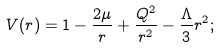Convert formula to latex. <formula><loc_0><loc_0><loc_500><loc_500>V ( r ) = 1 - \frac { 2 \mu } { r } + \frac { Q ^ { 2 } } { r ^ { 2 } } - \frac { \Lambda } { 3 } r ^ { 2 } ;</formula> 